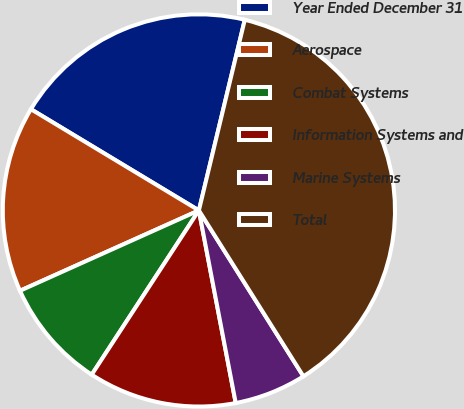Convert chart to OTSL. <chart><loc_0><loc_0><loc_500><loc_500><pie_chart><fcel>Year Ended December 31<fcel>Aerospace<fcel>Combat Systems<fcel>Information Systems and<fcel>Marine Systems<fcel>Total<nl><fcel>20.13%<fcel>15.35%<fcel>9.08%<fcel>12.21%<fcel>5.94%<fcel>37.29%<nl></chart> 